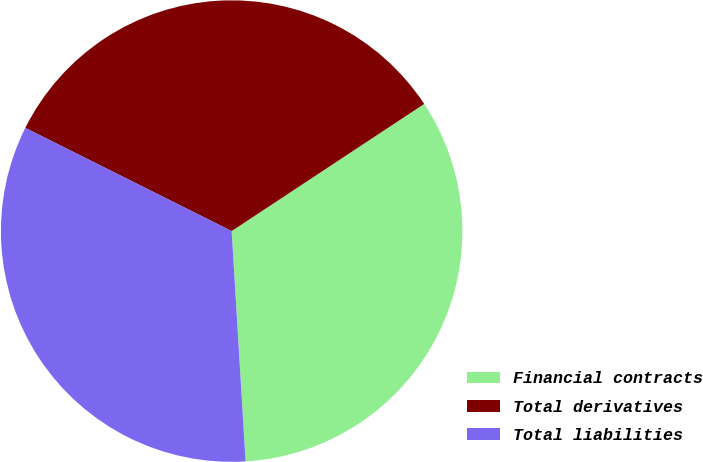Convert chart to OTSL. <chart><loc_0><loc_0><loc_500><loc_500><pie_chart><fcel>Financial contracts<fcel>Total derivatives<fcel>Total liabilities<nl><fcel>33.33%<fcel>33.33%<fcel>33.34%<nl></chart> 